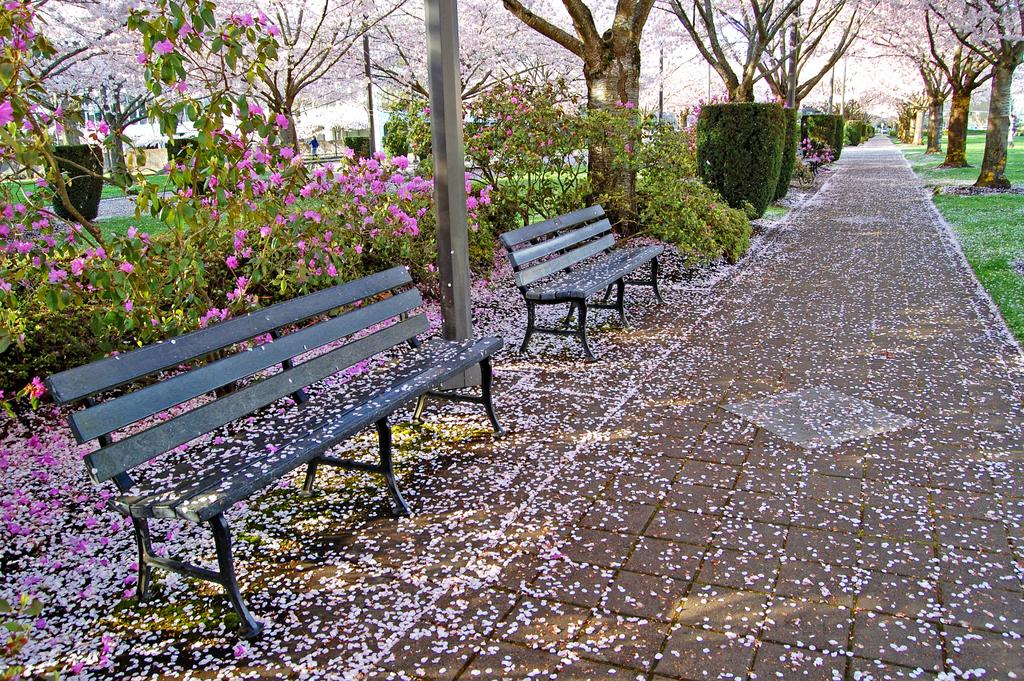What type of seating is present in the image? There are benches in the image. What type of pathway is visible in the image? There is a walkway in the image. What type of vegetation with flowers can be seen in the image? There are plants with flowers in the image. What type of ground cover is visible in the image? There is grass visible in the image. What type of tall vegetation is visible in the image? There are trees in the image. Can you tell me how many airplanes are flying in the image? There are no airplanes visible in the image. What type of gun is being used in the image? There are no guns present in the image. 